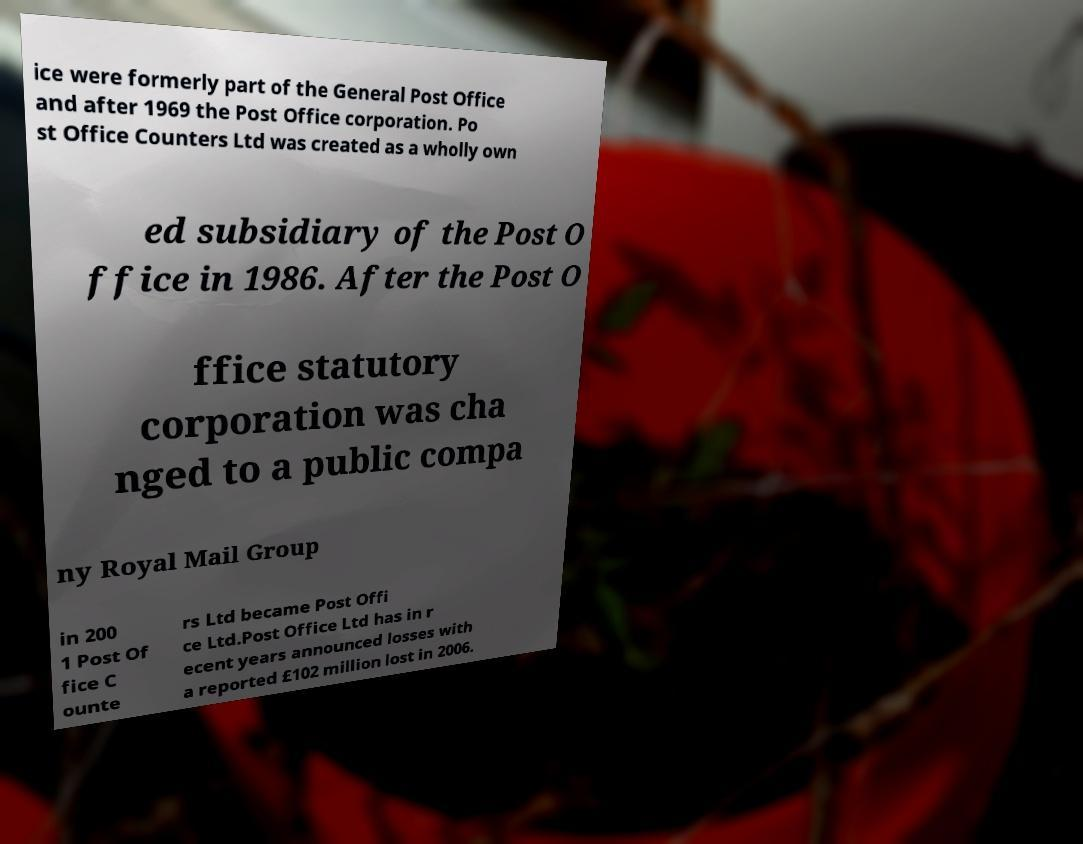Please read and relay the text visible in this image. What does it say? ice were formerly part of the General Post Office and after 1969 the Post Office corporation. Po st Office Counters Ltd was created as a wholly own ed subsidiary of the Post O ffice in 1986. After the Post O ffice statutory corporation was cha nged to a public compa ny Royal Mail Group in 200 1 Post Of fice C ounte rs Ltd became Post Offi ce Ltd.Post Office Ltd has in r ecent years announced losses with a reported £102 million lost in 2006. 